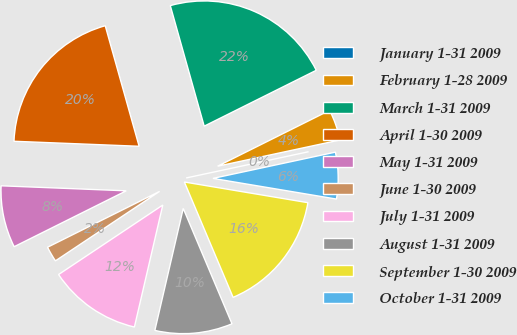<chart> <loc_0><loc_0><loc_500><loc_500><pie_chart><fcel>January 1-31 2009<fcel>February 1-28 2009<fcel>March 1-31 2009<fcel>April 1-30 2009<fcel>May 1-31 2009<fcel>June 1-30 2009<fcel>July 1-31 2009<fcel>August 1-31 2009<fcel>September 1-30 2009<fcel>October 1-31 2009<nl><fcel>0.0%<fcel>4.0%<fcel>22.0%<fcel>20.0%<fcel>8.0%<fcel>2.0%<fcel>12.0%<fcel>10.0%<fcel>16.0%<fcel>6.0%<nl></chart> 